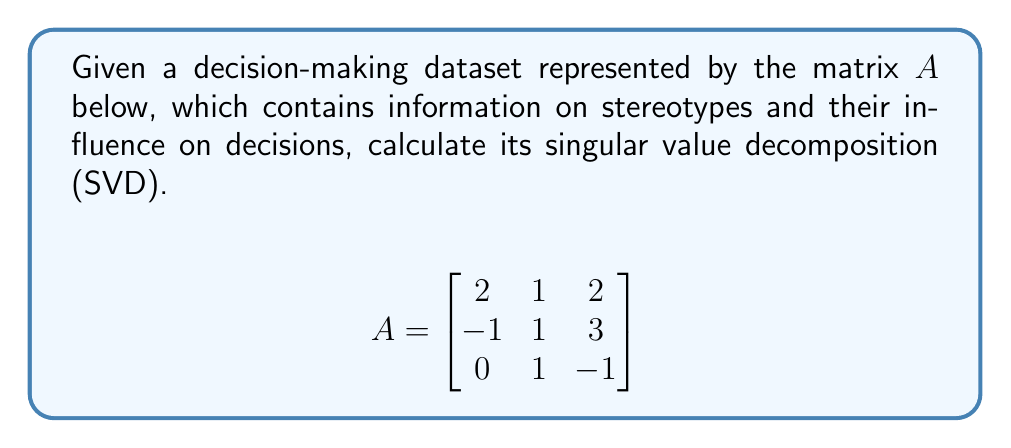Provide a solution to this math problem. To find the singular value decomposition of matrix $A$, we need to find matrices $U$, $\Sigma$, and $V^T$ such that $A = U\Sigma V^T$.

Step 1: Calculate $A^TA$ and $AA^T$
$$A^TA = \begin{bmatrix}
5 & 3 & 1 \\
3 & 3 & 1 \\
1 & 1 & 14
\end{bmatrix}$$

$$AA^T = \begin{bmatrix}
9 & 5 & 1 \\
5 & 11 & -2 \\
1 & -2 & 2
\end{bmatrix}$$

Step 2: Find eigenvalues of $A^TA$ (same as singular values squared)
Characteristic equation: $\det(A^TA - \lambda I) = 0$
$\lambda^3 - 22\lambda^2 + 131\lambda - 210 = 0$
Solving this, we get: $\lambda_1 = 15, \lambda_2 = 6, \lambda_3 = 1$

Step 3: Calculate singular values
$\sigma_1 = \sqrt{15}, \sigma_2 = \sqrt{6}, \sigma_3 = 1$

Step 4: Find eigenvectors of $A^TA$ to form columns of $V$
For $\lambda_1 = 15$: $v_1 = \frac{1}{\sqrt{6}}[1, 1, 2]^T$
For $\lambda_2 = 6$: $v_2 = \frac{1}{\sqrt{2}}[-1, 1, 0]^T$
For $\lambda_3 = 1$: $v_3 = \frac{1}{\sqrt{3}}[-1, -1, 1]^T$

Step 5: Calculate $U$ columns using $u_i = \frac{1}{\sigma_i}Av_i$
$u_1 = \frac{1}{\sqrt{90}}[5, 7, 2]^T$
$u_2 = \frac{1}{\sqrt{12}}[-1, 3, 1]^T$
$u_3 = \frac{1}{\sqrt{3}}[-1, 1, -1]^T$

Step 6: Form matrices $U$, $\Sigma$, and $V^T$
$$U = \begin{bmatrix}
\frac{5}{\sqrt{90}} & -\frac{1}{\sqrt{12}} & -\frac{1}{\sqrt{3}} \\
\frac{7}{\sqrt{90}} & \frac{3}{\sqrt{12}} & \frac{1}{\sqrt{3}} \\
\frac{2}{\sqrt{90}} & \frac{1}{\sqrt{12}} & -\frac{1}{\sqrt{3}}
\end{bmatrix}$$

$$\Sigma = \begin{bmatrix}
\sqrt{15} & 0 & 0 \\
0 & \sqrt{6} & 0 \\
0 & 0 & 1
\end{bmatrix}$$

$$V^T = \begin{bmatrix}
\frac{1}{\sqrt{6}} & \frac{1}{\sqrt{6}} & \frac{2}{\sqrt{6}} \\
-\frac{1}{\sqrt{2}} & \frac{1}{\sqrt{2}} & 0 \\
-\frac{1}{\sqrt{3}} & -\frac{1}{\sqrt{3}} & \frac{1}{\sqrt{3}}
\end{bmatrix}$$
Answer: $A = U\Sigma V^T$, where
$U = [\frac{5}{\sqrt{90}}, -\frac{1}{\sqrt{12}}, -\frac{1}{\sqrt{3}}; \frac{7}{\sqrt{90}}, \frac{3}{\sqrt{12}}, \frac{1}{\sqrt{3}}; \frac{2}{\sqrt{90}}, \frac{1}{\sqrt{12}}, -\frac{1}{\sqrt{3}}]$,
$\Sigma = [\sqrt{15}, 0, 0; 0, \sqrt{6}, 0; 0, 0, 1]$,
$V^T = [\frac{1}{\sqrt{6}}, \frac{1}{\sqrt{6}}, \frac{2}{\sqrt{6}}; -\frac{1}{\sqrt{2}}, \frac{1}{\sqrt{2}}, 0; -\frac{1}{\sqrt{3}}, -\frac{1}{\sqrt{3}}, \frac{1}{\sqrt{3}}]$ 